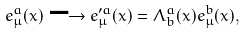<formula> <loc_0><loc_0><loc_500><loc_500>e _ { \mu } ^ { a } ( x ) \longrightarrow e _ { \mu } ^ { \prime a } ( x ) = \Lambda _ { b } ^ { a } ( x ) e _ { \mu } ^ { b } ( x ) ,</formula> 